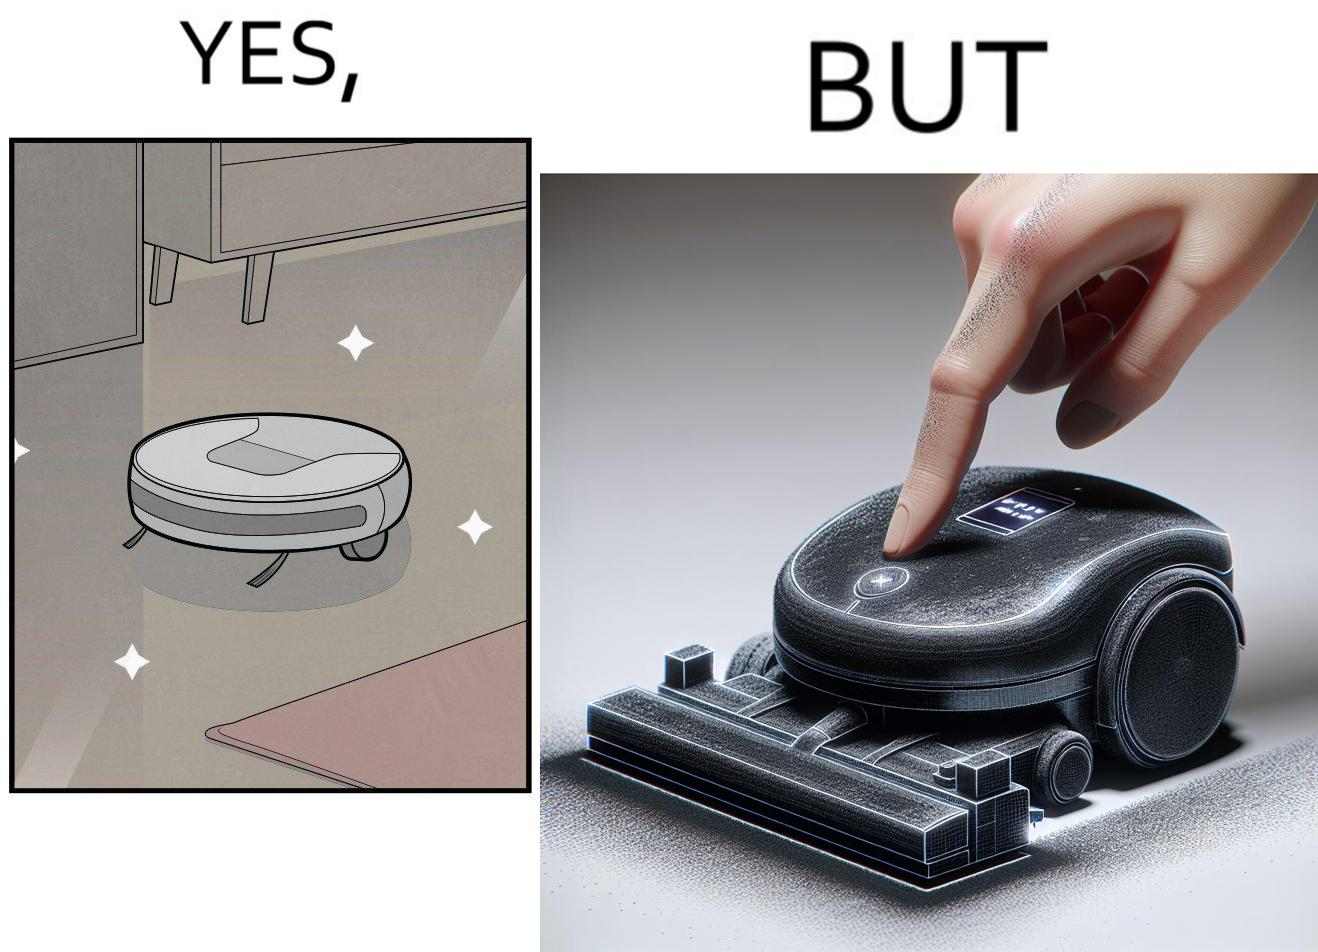Does this image contain satire or humor? Yes, this image is satirical. 